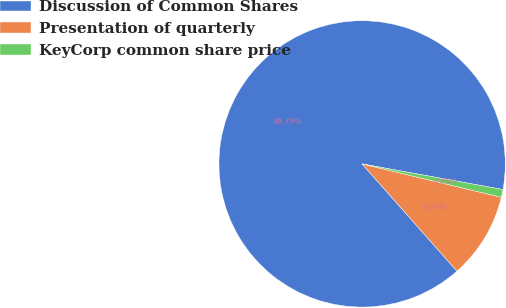Convert chart. <chart><loc_0><loc_0><loc_500><loc_500><pie_chart><fcel>Discussion of Common Shares<fcel>Presentation of quarterly<fcel>KeyCorp common share price<nl><fcel>89.38%<fcel>9.73%<fcel>0.88%<nl></chart> 